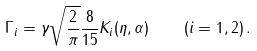Convert formula to latex. <formula><loc_0><loc_0><loc_500><loc_500>\Gamma _ { i } = \gamma \sqrt { \frac { 2 } { \pi } } \frac { 8 } { 1 5 } K _ { i } ( \eta , \alpha ) \quad ( i = 1 , 2 ) \, .</formula> 